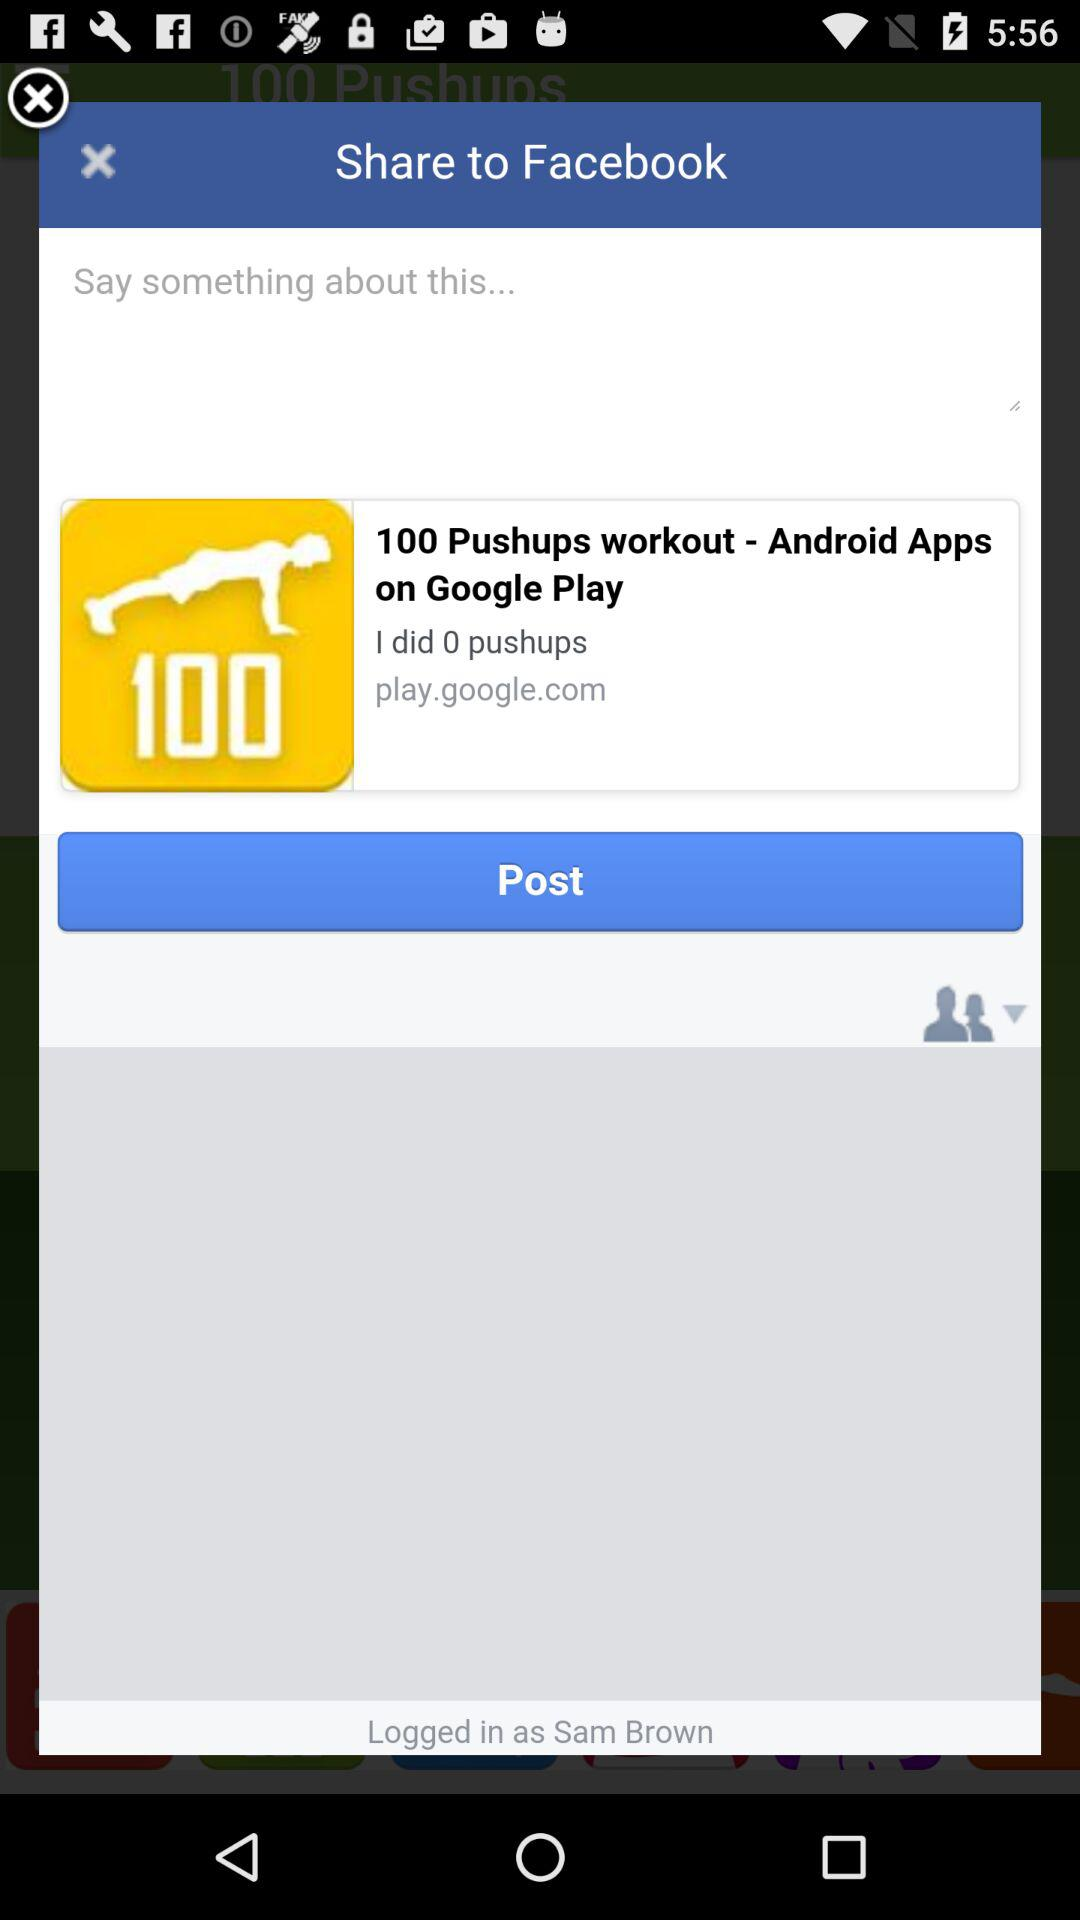When were the pushups completed?
When the provided information is insufficient, respond with <no answer>. <no answer> 